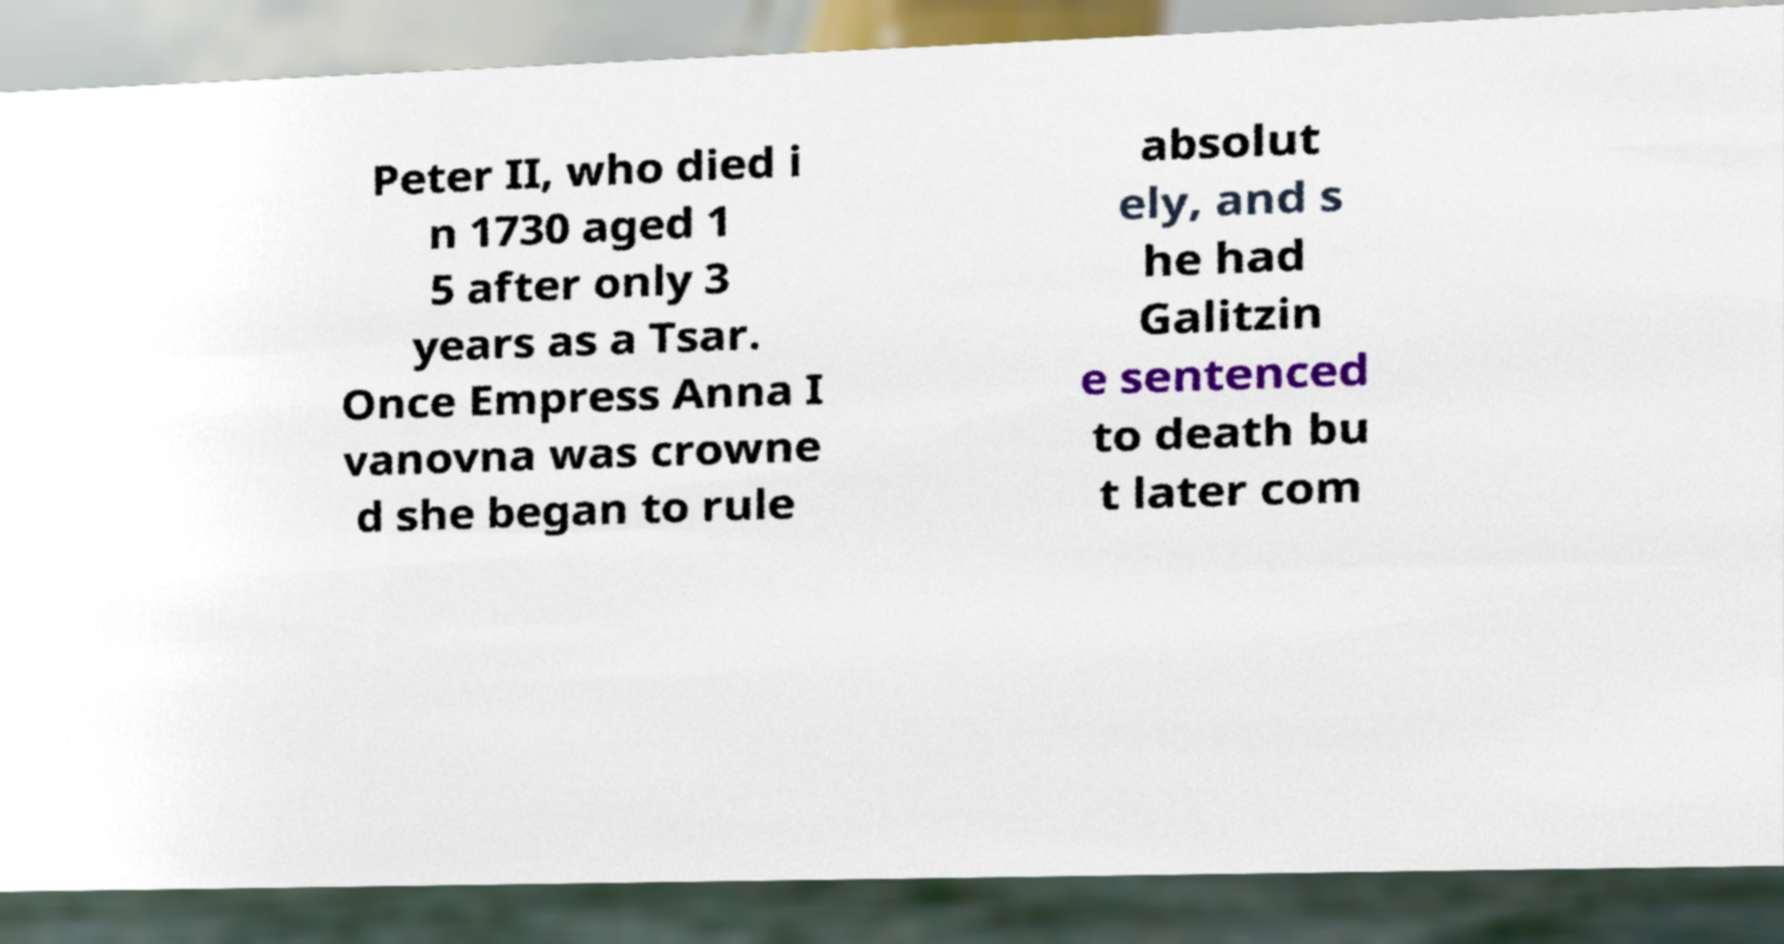Could you assist in decoding the text presented in this image and type it out clearly? Peter II, who died i n 1730 aged 1 5 after only 3 years as a Tsar. Once Empress Anna I vanovna was crowne d she began to rule absolut ely, and s he had Galitzin e sentenced to death bu t later com 